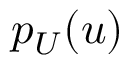<formula> <loc_0><loc_0><loc_500><loc_500>p _ { U } ( u )</formula> 